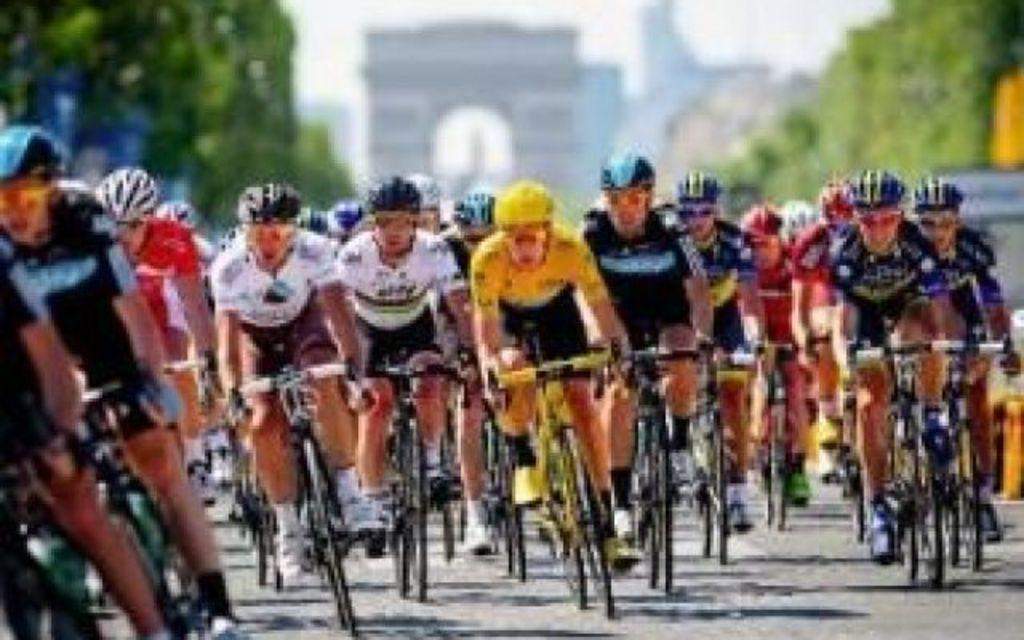What are the people in the image doing? The people in the image are riding bicycles. Where are the people riding their bicycles? The people are on the road. Can you describe the background of the image? The background is blurred, but there is an arch visible, along with trees and the sky. What type of food is the horse eating in the image? There is no horse present in the image, so it is not possible to determine what, if any, food the horse might be eating. 